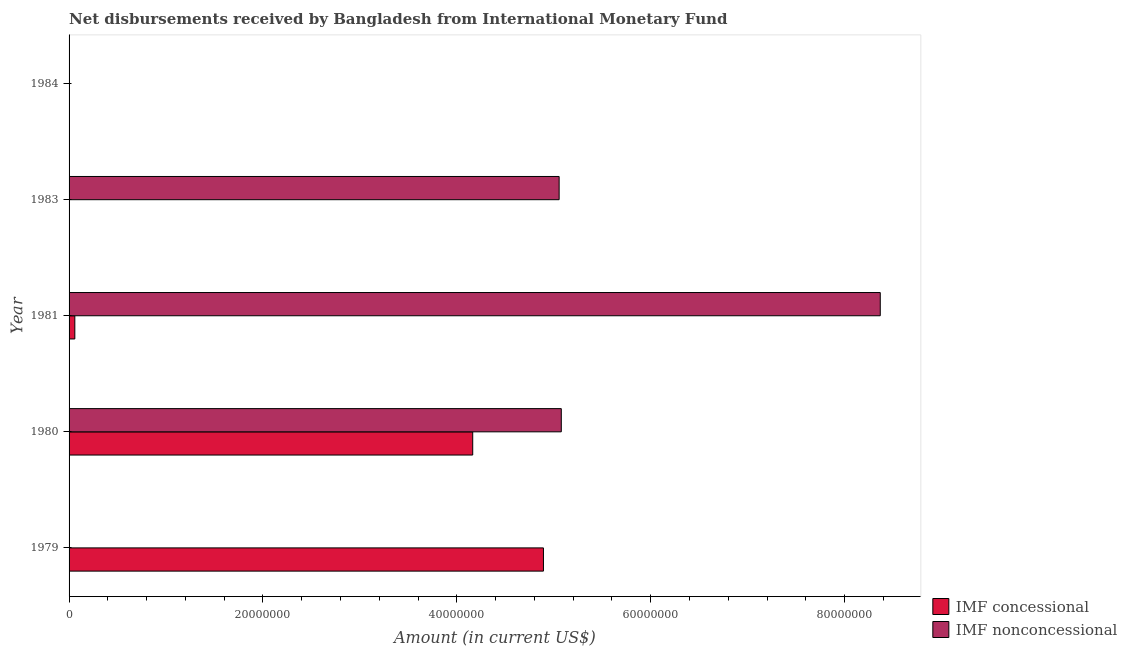Are the number of bars per tick equal to the number of legend labels?
Provide a succinct answer. No. What is the net non concessional disbursements from imf in 1979?
Offer a terse response. 0. Across all years, what is the maximum net concessional disbursements from imf?
Provide a succinct answer. 4.89e+07. Across all years, what is the minimum net non concessional disbursements from imf?
Ensure brevity in your answer.  0. What is the total net non concessional disbursements from imf in the graph?
Give a very brief answer. 1.85e+08. What is the difference between the net concessional disbursements from imf in 1980 and that in 1981?
Make the answer very short. 4.10e+07. What is the difference between the net concessional disbursements from imf in 1980 and the net non concessional disbursements from imf in 1981?
Make the answer very short. -4.20e+07. What is the average net concessional disbursements from imf per year?
Your response must be concise. 1.82e+07. In the year 1981, what is the difference between the net non concessional disbursements from imf and net concessional disbursements from imf?
Your response must be concise. 8.31e+07. In how many years, is the net non concessional disbursements from imf greater than 36000000 US$?
Ensure brevity in your answer.  3. What is the ratio of the net non concessional disbursements from imf in 1980 to that in 1981?
Your answer should be very brief. 0.61. Is the difference between the net non concessional disbursements from imf in 1980 and 1981 greater than the difference between the net concessional disbursements from imf in 1980 and 1981?
Give a very brief answer. No. What is the difference between the highest and the second highest net non concessional disbursements from imf?
Offer a very short reply. 3.29e+07. What is the difference between the highest and the lowest net concessional disbursements from imf?
Provide a succinct answer. 4.89e+07. What is the difference between two consecutive major ticks on the X-axis?
Offer a terse response. 2.00e+07. Are the values on the major ticks of X-axis written in scientific E-notation?
Your response must be concise. No. Does the graph contain grids?
Your response must be concise. No. Where does the legend appear in the graph?
Keep it short and to the point. Bottom right. What is the title of the graph?
Provide a succinct answer. Net disbursements received by Bangladesh from International Monetary Fund. What is the label or title of the X-axis?
Your answer should be very brief. Amount (in current US$). What is the label or title of the Y-axis?
Keep it short and to the point. Year. What is the Amount (in current US$) of IMF concessional in 1979?
Provide a succinct answer. 4.89e+07. What is the Amount (in current US$) of IMF nonconcessional in 1979?
Ensure brevity in your answer.  0. What is the Amount (in current US$) in IMF concessional in 1980?
Keep it short and to the point. 4.16e+07. What is the Amount (in current US$) in IMF nonconcessional in 1980?
Offer a terse response. 5.08e+07. What is the Amount (in current US$) in IMF concessional in 1981?
Your response must be concise. 5.94e+05. What is the Amount (in current US$) of IMF nonconcessional in 1981?
Offer a very short reply. 8.37e+07. What is the Amount (in current US$) in IMF nonconcessional in 1983?
Offer a very short reply. 5.06e+07. What is the Amount (in current US$) of IMF concessional in 1984?
Offer a terse response. 0. Across all years, what is the maximum Amount (in current US$) of IMF concessional?
Your answer should be very brief. 4.89e+07. Across all years, what is the maximum Amount (in current US$) of IMF nonconcessional?
Offer a terse response. 8.37e+07. Across all years, what is the minimum Amount (in current US$) of IMF concessional?
Give a very brief answer. 0. What is the total Amount (in current US$) in IMF concessional in the graph?
Your response must be concise. 9.12e+07. What is the total Amount (in current US$) of IMF nonconcessional in the graph?
Offer a terse response. 1.85e+08. What is the difference between the Amount (in current US$) in IMF concessional in 1979 and that in 1980?
Keep it short and to the point. 7.30e+06. What is the difference between the Amount (in current US$) in IMF concessional in 1979 and that in 1981?
Offer a terse response. 4.83e+07. What is the difference between the Amount (in current US$) in IMF concessional in 1980 and that in 1981?
Provide a succinct answer. 4.10e+07. What is the difference between the Amount (in current US$) in IMF nonconcessional in 1980 and that in 1981?
Your answer should be very brief. -3.29e+07. What is the difference between the Amount (in current US$) of IMF nonconcessional in 1980 and that in 1983?
Ensure brevity in your answer.  2.24e+05. What is the difference between the Amount (in current US$) of IMF nonconcessional in 1981 and that in 1983?
Provide a short and direct response. 3.31e+07. What is the difference between the Amount (in current US$) in IMF concessional in 1979 and the Amount (in current US$) in IMF nonconcessional in 1980?
Offer a terse response. -1.84e+06. What is the difference between the Amount (in current US$) of IMF concessional in 1979 and the Amount (in current US$) of IMF nonconcessional in 1981?
Provide a short and direct response. -3.47e+07. What is the difference between the Amount (in current US$) of IMF concessional in 1979 and the Amount (in current US$) of IMF nonconcessional in 1983?
Give a very brief answer. -1.62e+06. What is the difference between the Amount (in current US$) in IMF concessional in 1980 and the Amount (in current US$) in IMF nonconcessional in 1981?
Your answer should be very brief. -4.20e+07. What is the difference between the Amount (in current US$) of IMF concessional in 1980 and the Amount (in current US$) of IMF nonconcessional in 1983?
Provide a short and direct response. -8.91e+06. What is the difference between the Amount (in current US$) of IMF concessional in 1981 and the Amount (in current US$) of IMF nonconcessional in 1983?
Keep it short and to the point. -5.00e+07. What is the average Amount (in current US$) of IMF concessional per year?
Ensure brevity in your answer.  1.82e+07. What is the average Amount (in current US$) in IMF nonconcessional per year?
Offer a very short reply. 3.70e+07. In the year 1980, what is the difference between the Amount (in current US$) of IMF concessional and Amount (in current US$) of IMF nonconcessional?
Ensure brevity in your answer.  -9.14e+06. In the year 1981, what is the difference between the Amount (in current US$) of IMF concessional and Amount (in current US$) of IMF nonconcessional?
Your response must be concise. -8.31e+07. What is the ratio of the Amount (in current US$) in IMF concessional in 1979 to that in 1980?
Your answer should be compact. 1.18. What is the ratio of the Amount (in current US$) in IMF concessional in 1979 to that in 1981?
Provide a short and direct response. 82.38. What is the ratio of the Amount (in current US$) of IMF concessional in 1980 to that in 1981?
Your answer should be very brief. 70.1. What is the ratio of the Amount (in current US$) of IMF nonconcessional in 1980 to that in 1981?
Ensure brevity in your answer.  0.61. What is the ratio of the Amount (in current US$) of IMF nonconcessional in 1980 to that in 1983?
Ensure brevity in your answer.  1. What is the ratio of the Amount (in current US$) in IMF nonconcessional in 1981 to that in 1983?
Keep it short and to the point. 1.66. What is the difference between the highest and the second highest Amount (in current US$) in IMF concessional?
Offer a very short reply. 7.30e+06. What is the difference between the highest and the second highest Amount (in current US$) of IMF nonconcessional?
Give a very brief answer. 3.29e+07. What is the difference between the highest and the lowest Amount (in current US$) of IMF concessional?
Your answer should be compact. 4.89e+07. What is the difference between the highest and the lowest Amount (in current US$) of IMF nonconcessional?
Give a very brief answer. 8.37e+07. 